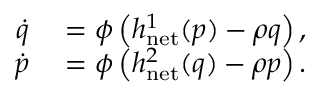<formula> <loc_0><loc_0><loc_500><loc_500>\begin{array} { r } { \begin{array} { r l } { \dot { q } } & = \phi \left ( h _ { n e t } ^ { 1 } ( p ) - \rho q \right ) , } \\ { \dot { p } } & = \phi \left ( h _ { n e t } ^ { 2 } ( q ) - \rho p \right ) . } \end{array} } \end{array}</formula> 